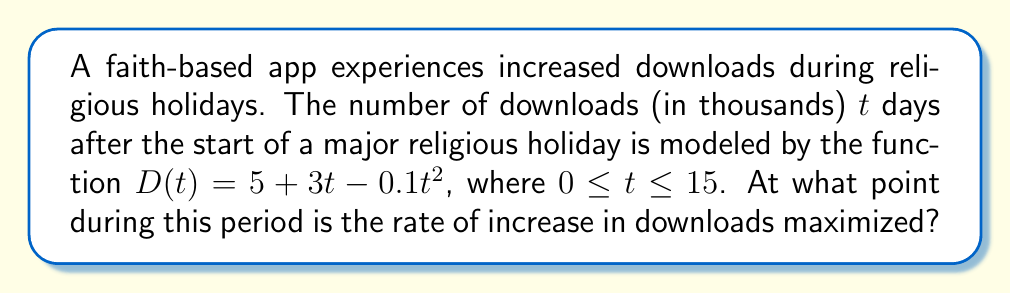Show me your answer to this math problem. To find when the rate of increase in downloads is maximized, we need to follow these steps:

1) The rate of increase is given by the first derivative of $D(t)$. Let's call this $D'(t)$.

   $D'(t) = \frac{d}{dt}(5 + 3t - 0.1t^2) = 3 - 0.2t$

2) The rate of increase will be maximized when the second derivative $D''(t)$ equals zero.

   $D''(t) = \frac{d}{dt}(3 - 0.2t) = -0.2$

3) Since $D''(t)$ is a constant and negative, the rate of increase is maximized when $D'(t)$ is at its highest value.

4) Given the domain $0 \leq t \leq 15$, $D'(t)$ will be highest at $t = 0$:

   $D'(0) = 3 - 0.2(0) = 3$

5) We can verify this:
   At $t = 15$: $D'(15) = 3 - 0.2(15) = 0$
   
   So $D'(t)$ decreases from 3 to 0 over the given interval.

Therefore, the rate of increase in downloads is maximized at the start of the holiday period, when $t = 0$.
Answer: $t = 0$ 